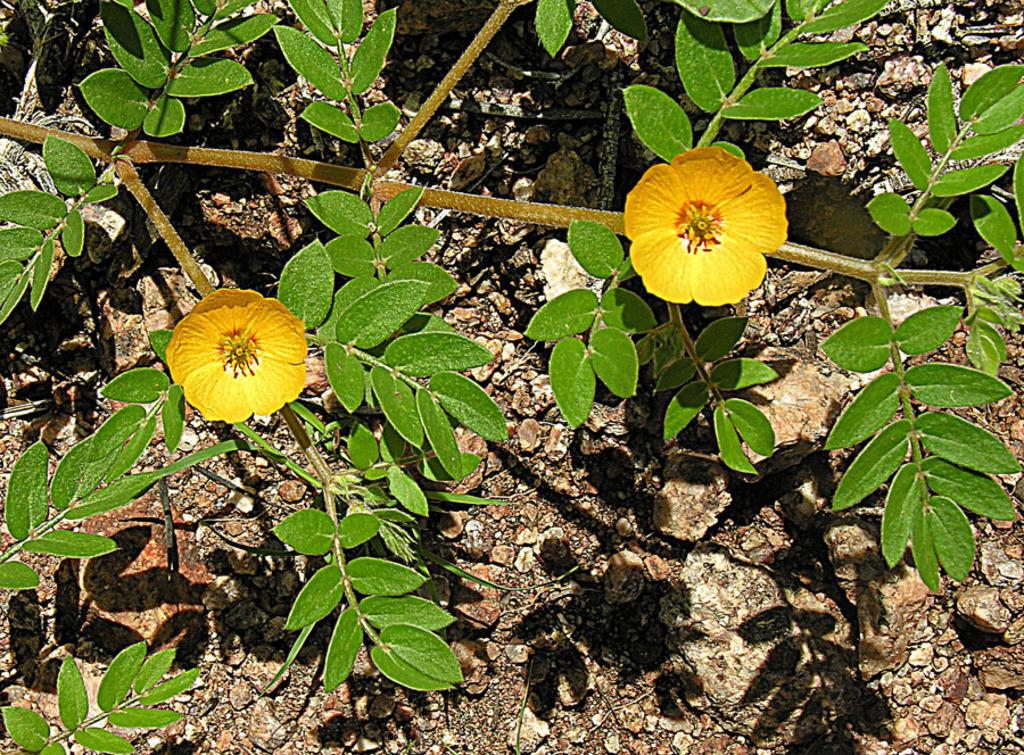What can be seen in the image? There is a branch in the image. What is special about the branch? The branch contains leaves and flowers. What role does the father play in the image? There is no father present in the image; it only features a branch with leaves and flowers. What type of scissors can be seen cutting the flowers in the image? There are no scissors present in the image, and no flowers are being cut. 